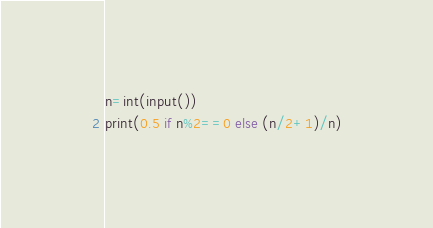<code> <loc_0><loc_0><loc_500><loc_500><_Python_>n=int(input())
print(0.5 if n%2==0 else (n/2+1)/n)</code> 